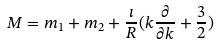Convert formula to latex. <formula><loc_0><loc_0><loc_500><loc_500>M = m _ { 1 } + m _ { 2 } + \frac { \imath } { R } ( { k } \frac { \partial } { \partial { k } } + \frac { 3 } { 2 } )</formula> 